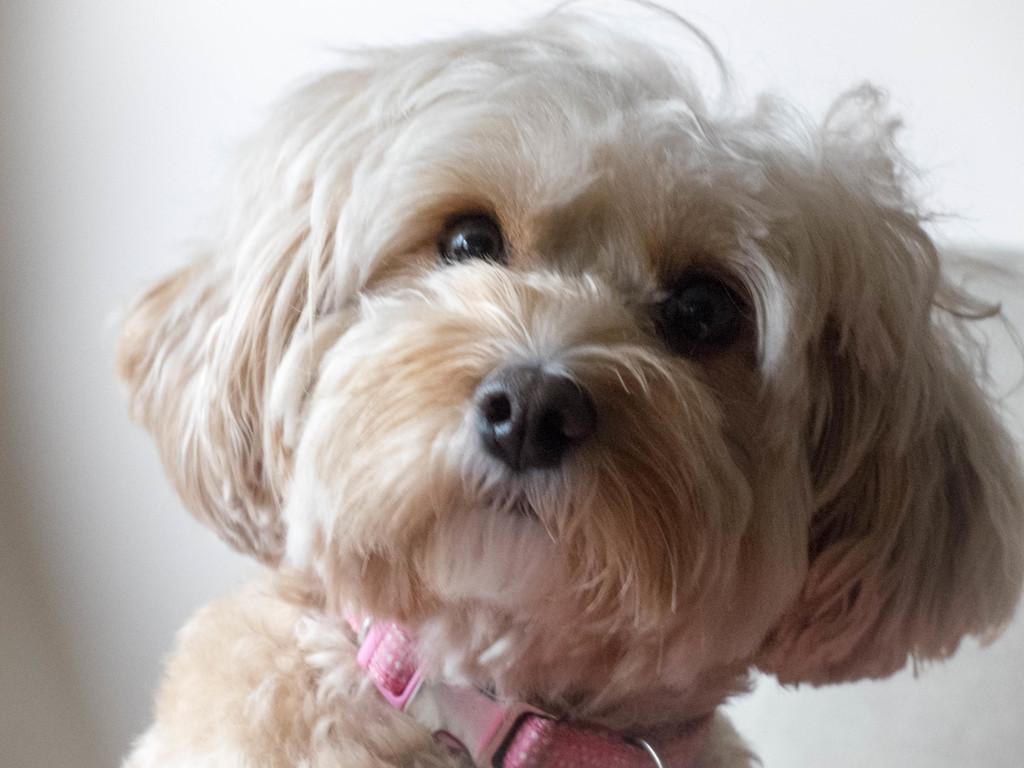Please provide a concise description of this image. In this image I can see a dog which is in cream color, at back the wall is also in cream color. 